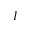<formula> <loc_0><loc_0><loc_500><loc_500>I</formula> 